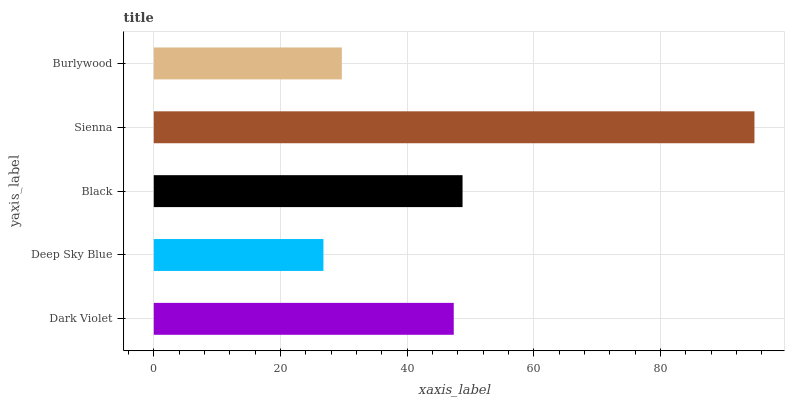Is Deep Sky Blue the minimum?
Answer yes or no. Yes. Is Sienna the maximum?
Answer yes or no. Yes. Is Black the minimum?
Answer yes or no. No. Is Black the maximum?
Answer yes or no. No. Is Black greater than Deep Sky Blue?
Answer yes or no. Yes. Is Deep Sky Blue less than Black?
Answer yes or no. Yes. Is Deep Sky Blue greater than Black?
Answer yes or no. No. Is Black less than Deep Sky Blue?
Answer yes or no. No. Is Dark Violet the high median?
Answer yes or no. Yes. Is Dark Violet the low median?
Answer yes or no. Yes. Is Burlywood the high median?
Answer yes or no. No. Is Sienna the low median?
Answer yes or no. No. 